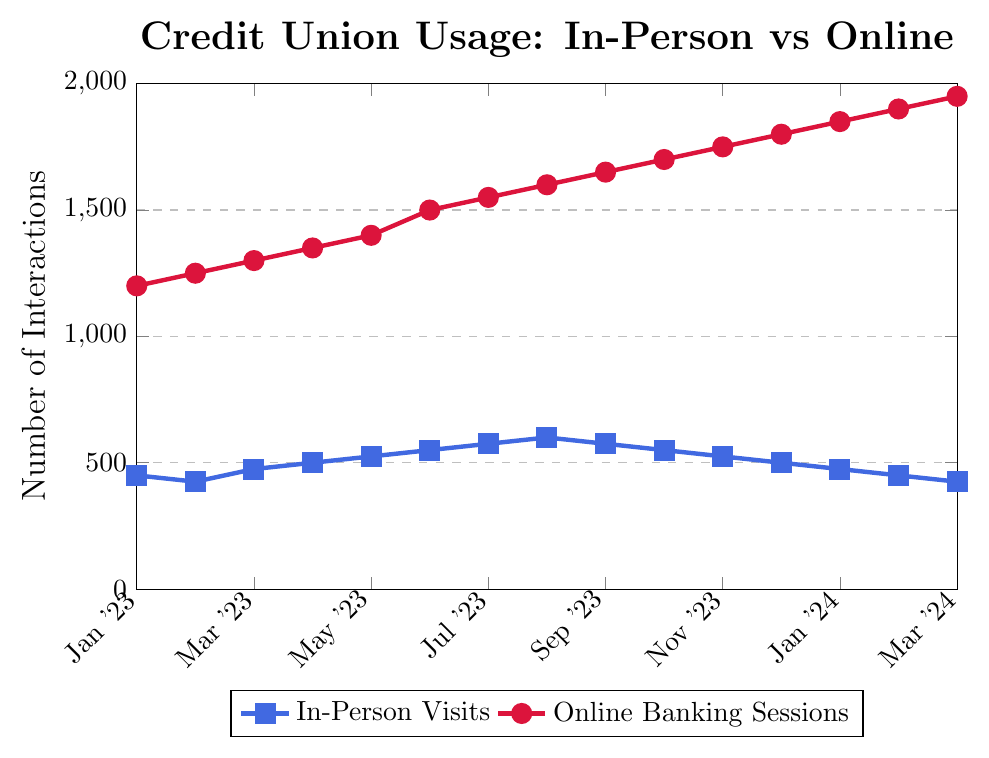what is the difference in the number of in-person visits between Jan 2023 and Jul 2023? The number of in-person visits in Jan 2023 is 450, and in Jul 2023 it is 575. The difference is 575 - 450.
Answer: 125 how do the trends of in-person visits and online banking sessions compare from Jan 2023 to Mar 2024? Both in-person visits and online banking sessions show an increasing trend, but the rate of increase for online banking sessions is faster compared to in-person visits. Online banking sessions rise from 1200 to 1950, while in-person visits range from 450 to 425 over the same period.
Answer: Both increase; online banking increases faster what is the peak month for in-person visits? By observing the peak in the plot, in-person visits reach their maximum value in Aug 2023.
Answer: Aug 2023 which month showed the highest number of online banking sessions? The plot shows that the highest number of online banking sessions is in Mar 2024.
Answer: Mar 2024 are there any months where in-person visits remain the same or decrease? In-person visits remain the same from Sep 2023 to Oct 2023 at 575 events, and they show a decreasing trend from Aug 2023 to Mar 2024.
Answer: Sep 2023, Oct 2023 (remain same), decrease from Aug 2023 to Mar 2024 what was the overall trend for online banking sessions in 2023? Online banking sessions consistently increased throughout 2023, starting from 1200 in Jan 2023 to 1800 in Dec 2023.
Answer: Consistent increase what is the average number of online banking sessions in 2023? Summing the monthly online banking sessions in 2023 (1200 + 1250 + 1300 + 1350 + 1400 + 1500 + 1550 + 1600 + 1650 + 1700 + 1750 + 1800) gives 18050. There are 12 months, so the average is 18050 / 12.
Answer: 1504.17 in which month is the gap between in-person visits and online banking sessions the largest? By calculating the difference for each month, the largest gap is in Mar 2024, with 1950 online banking sessions and 425 in-person visits. The gap is 1950 - 425.
Answer: Mar 2024 how much did online banking sessions increase from Jan 2023 to Feb 2024? Online banking sessions increased from 1200 in Jan 2023 to 1900 in Feb 2024. The increase is 1900 - 1200.
Answer: 700 